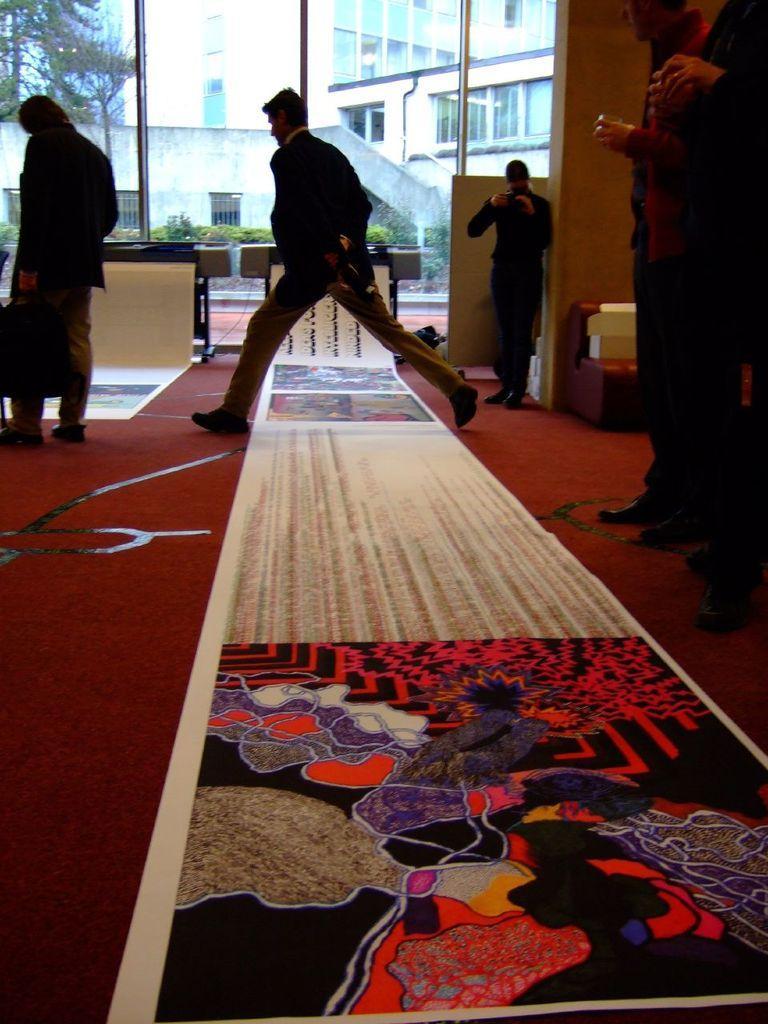In one or two sentences, can you explain what this image depicts? In the picture I can see some white color banner is placed on the floor and a person is crossing over it. On the right side of the image I can see people holding cameras in their hands and standing and we can see another person standing on the left side of the image. In the background, I can see tables and boards, I can see the glass doors through which we can see buildings and trees. 